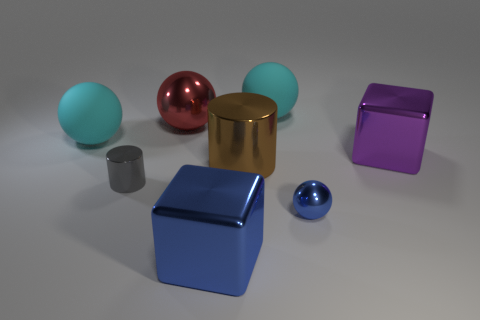What materials do these objects seem to be made of? The objects in the image showcase a variety of textures that suggest they could be made of different materials. The two balls and the cylinder have reflective surfaces indicative of metal. Meanwhile, the other objects, despite having a sheen, do not reflect their environment as clearly, hinting at a possible plastic or coated material composition. 